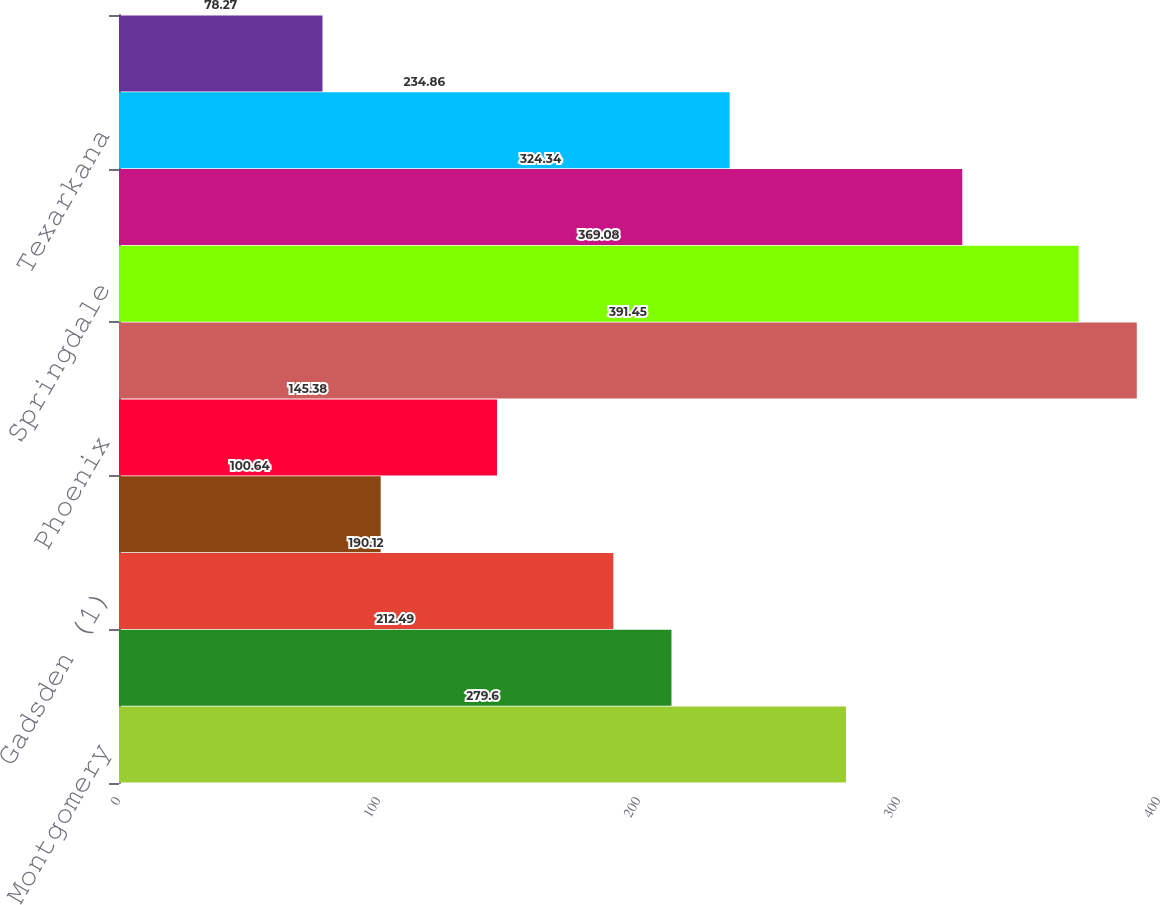Convert chart to OTSL. <chart><loc_0><loc_0><loc_500><loc_500><bar_chart><fcel>Montgomery<fcel>Albertville<fcel>Gadsden (1)<fcel>Birmingham<fcel>Phoenix<fcel>Russellville<fcel>Springdale<fcel>West Memphis<fcel>Texarkana<fcel>Fort Smith<nl><fcel>279.6<fcel>212.49<fcel>190.12<fcel>100.64<fcel>145.38<fcel>391.45<fcel>369.08<fcel>324.34<fcel>234.86<fcel>78.27<nl></chart> 